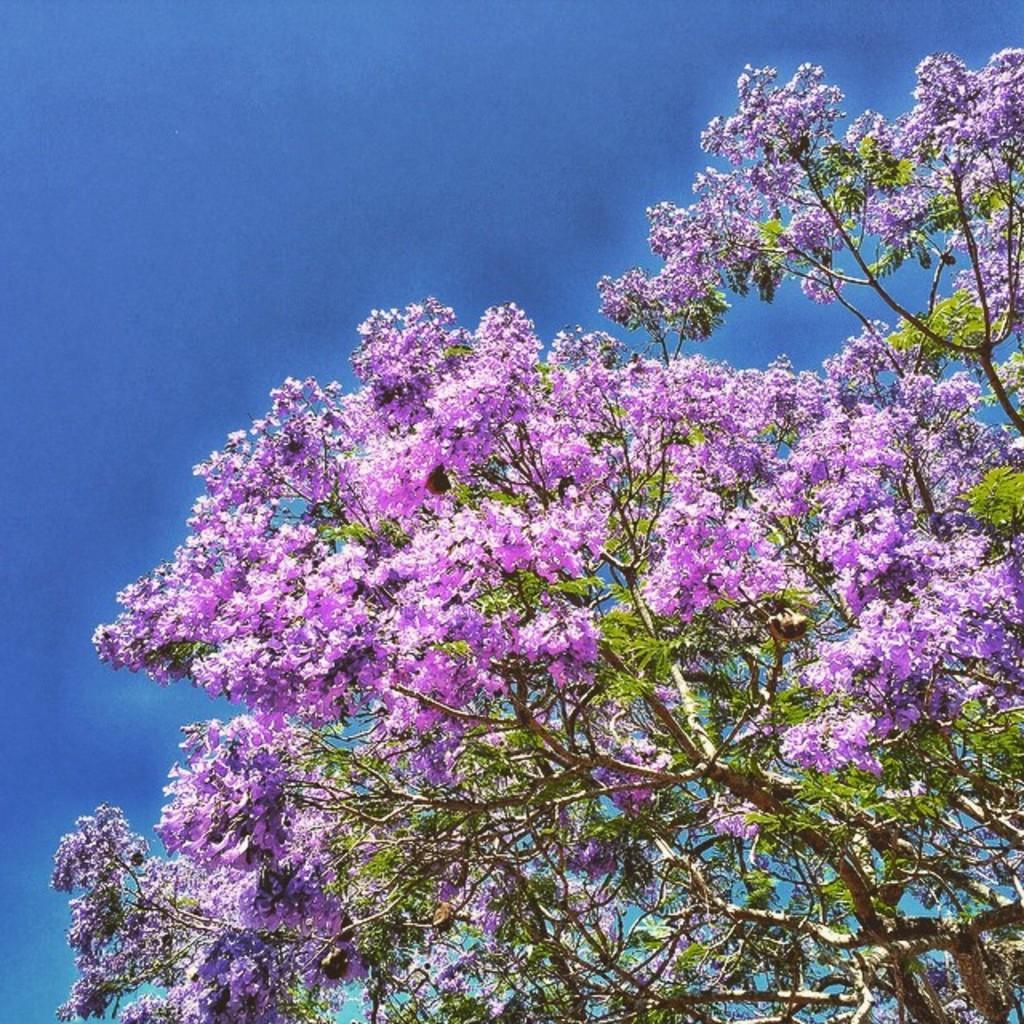How would you summarize this image in a sentence or two? In this image there is a tree with blue flowers, in the background there is a blue sky. 